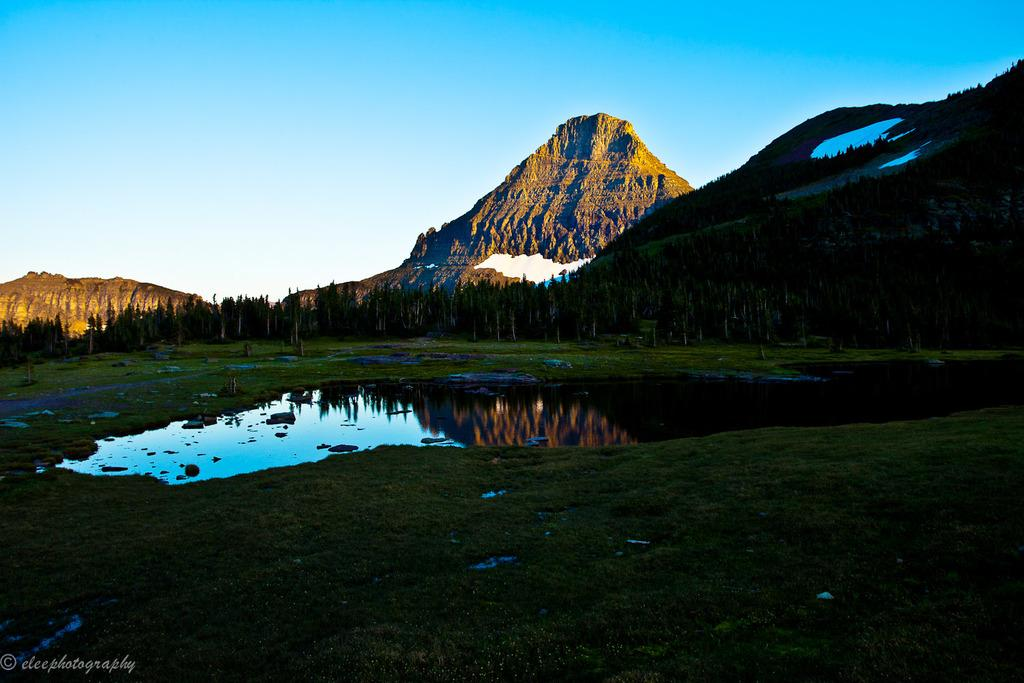What type of terrain is visible at the bottom of the image? There is grass at the bottom of the image. What is located in the middle of the image? There is water in the middle of the image. What can be seen in the background of the image? There are trees and hills in the background of the image. What is visible at the top of the image? The sky is visible at the top of the image. Where is the office located in the image? There is no office present in the image. Can you see a rifle in the image? There is no rifle present in the image. 